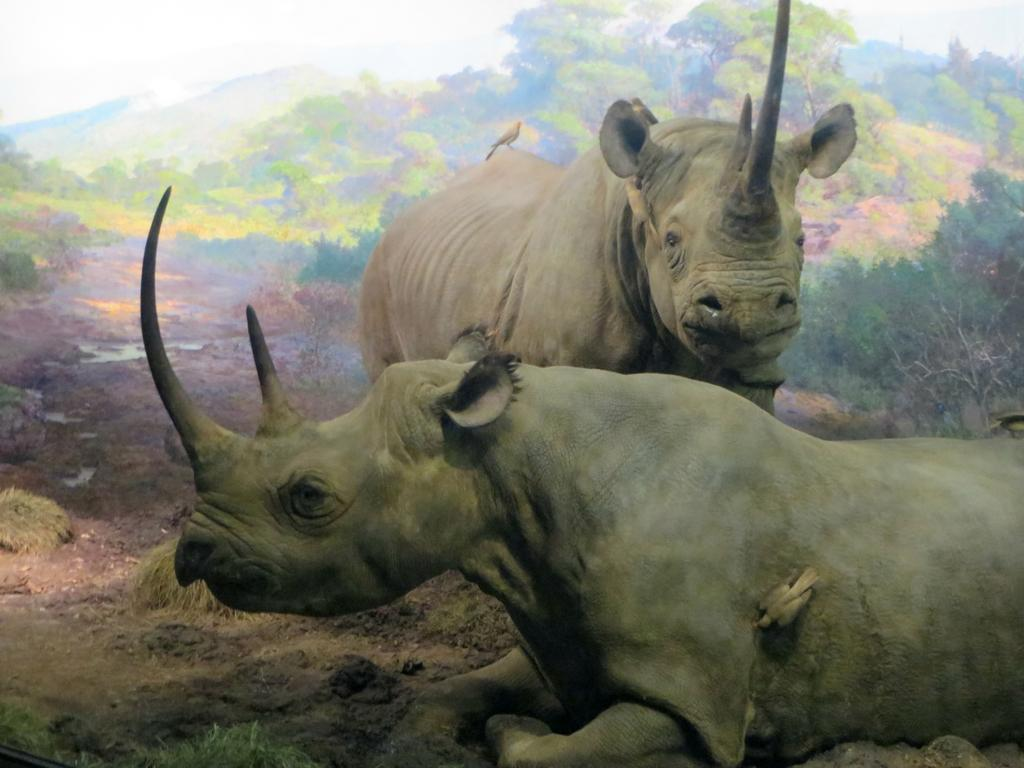What animals are in the middle of the image? There are two rhinoceros in the middle of the image. What is the position of one of the rhinoceros? One rhinoceros is standing. What is the position of the other rhinoceros? Another rhinoceros is sleeping on the ground at the bottom of the image. What type of wrist accessory is visible on the sleeping rhinoceros? There is no wrist accessory visible on the sleeping rhinoceros, as rhinoceros do not typically wear such items. 